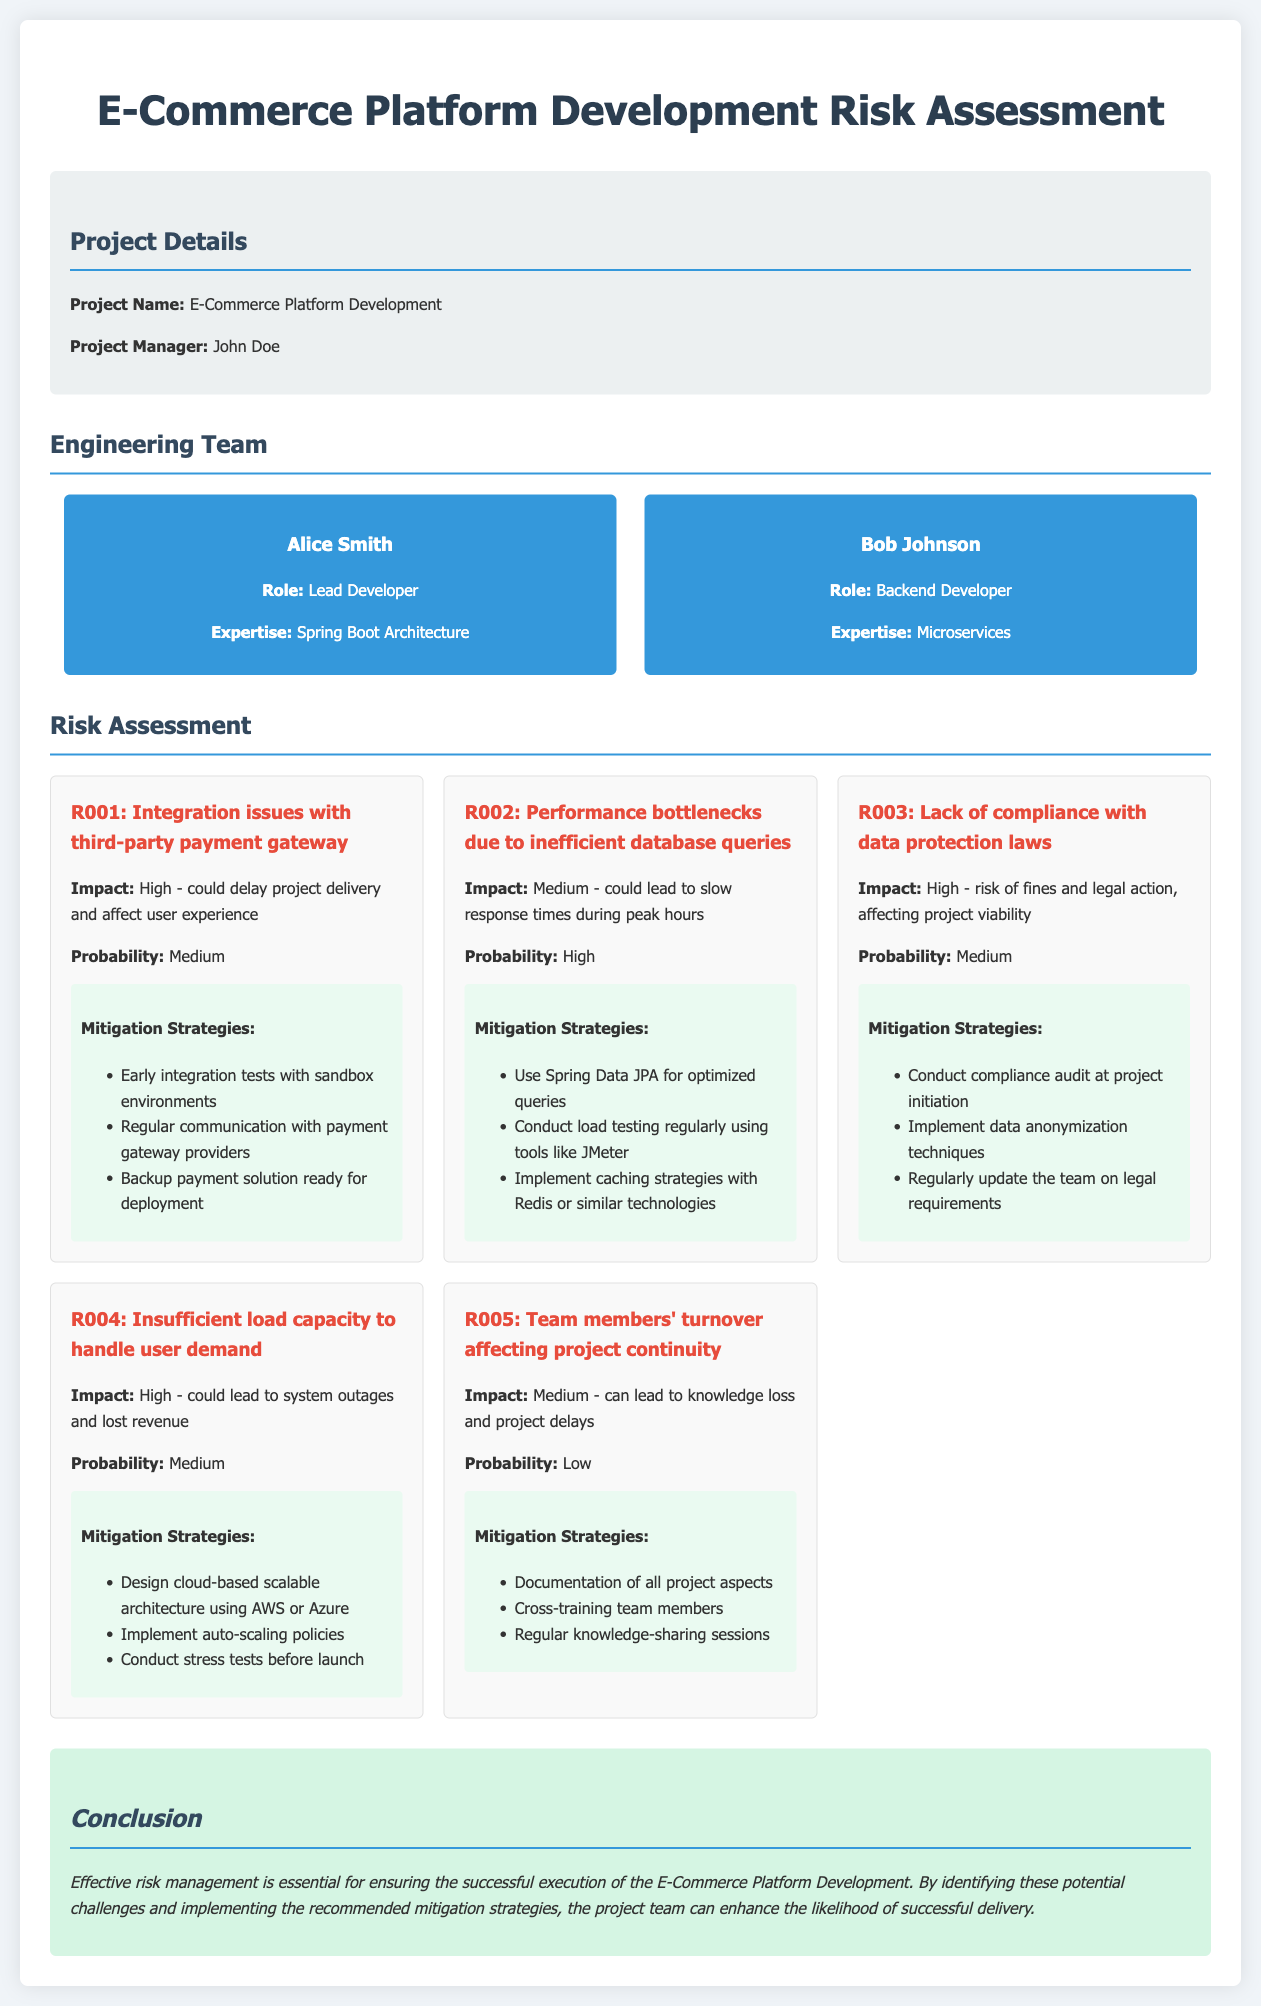What is the project name? The project name is listed in the project details section of the document.
Answer: E-Commerce Platform Development Who is the project manager? The project manager is named in the project details section of the document.
Answer: John Doe What is the role of Alice Smith? Alice Smith's role is provided in the engineering team section.
Answer: Lead Developer What is the impact level of R001? The impact level for R001 is described in the risk details section of the document.
Answer: High What mitigation strategy is suggested for performance bottlenecks? The mitigation strategies for performance bottlenecks are outlined under the specific risk in the document.
Answer: Use Spring Data JPA for optimized queries How many risks are listed in the document? The total number of risks can be counted from the risk assessment section.
Answer: Five What is the probability of insufficient load capacity affecting user demand? The probability for insufficient load capacity is mentioned in the risk details of the document.
Answer: Medium What strategy is recommended for team turnover? The recommended strategy for handling team turnover is found in the mitigation strategies for that risk.
Answer: Documentation of all project aspects What is a potential consequence of lacking compliance with data protection laws? The consequence of non-compliance is stated in the risk assessment section of the document.
Answer: Risk of fines and legal action 